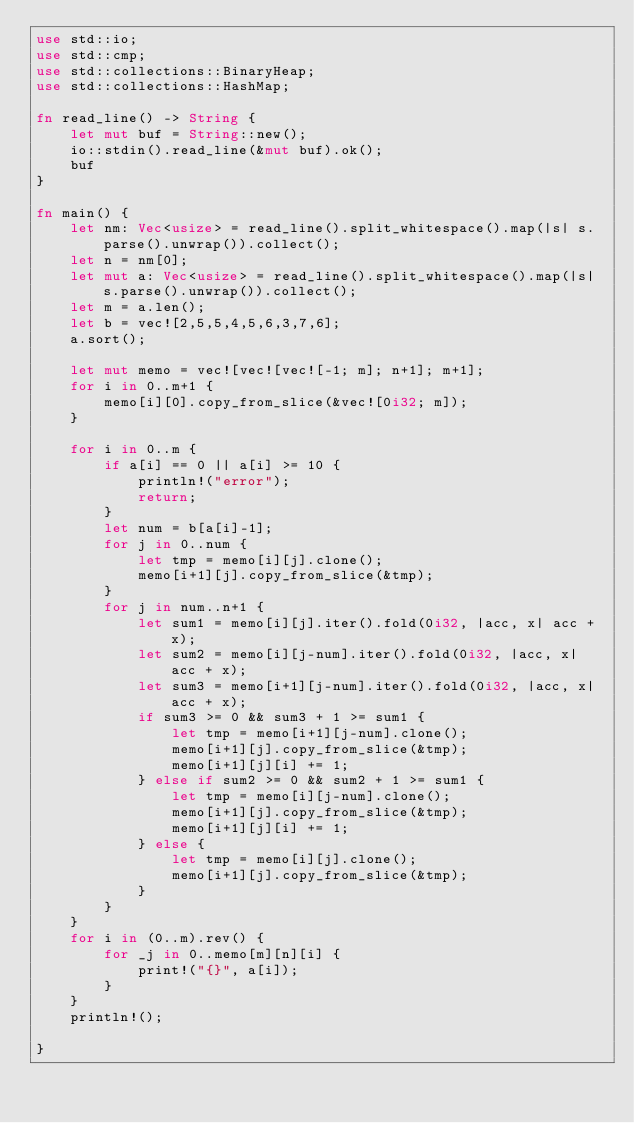<code> <loc_0><loc_0><loc_500><loc_500><_Rust_>use std::io;
use std::cmp;
use std::collections::BinaryHeap;
use std::collections::HashMap;

fn read_line() -> String {
    let mut buf = String::new();
    io::stdin().read_line(&mut buf).ok();
    buf
}

fn main() {
    let nm: Vec<usize> = read_line().split_whitespace().map(|s| s.parse().unwrap()).collect();
    let n = nm[0];
    let mut a: Vec<usize> = read_line().split_whitespace().map(|s| s.parse().unwrap()).collect();
    let m = a.len();
    let b = vec![2,5,5,4,5,6,3,7,6];
    a.sort();

    let mut memo = vec![vec![vec![-1; m]; n+1]; m+1];
    for i in 0..m+1 {
        memo[i][0].copy_from_slice(&vec![0i32; m]);
    }

    for i in 0..m {
        if a[i] == 0 || a[i] >= 10 {
            println!("error");
            return;
        }
        let num = b[a[i]-1];
        for j in 0..num {
            let tmp = memo[i][j].clone();
            memo[i+1][j].copy_from_slice(&tmp);
        }
        for j in num..n+1 {
            let sum1 = memo[i][j].iter().fold(0i32, |acc, x| acc + x);
            let sum2 = memo[i][j-num].iter().fold(0i32, |acc, x| acc + x);
            let sum3 = memo[i+1][j-num].iter().fold(0i32, |acc, x| acc + x);
            if sum3 >= 0 && sum3 + 1 >= sum1 {
                let tmp = memo[i+1][j-num].clone();
                memo[i+1][j].copy_from_slice(&tmp);
                memo[i+1][j][i] += 1;
            } else if sum2 >= 0 && sum2 + 1 >= sum1 {
                let tmp = memo[i][j-num].clone();
                memo[i+1][j].copy_from_slice(&tmp);
                memo[i+1][j][i] += 1;
            } else {
                let tmp = memo[i][j].clone();
                memo[i+1][j].copy_from_slice(&tmp);
            }
        }
    }
    for i in (0..m).rev() {
        for _j in 0..memo[m][n][i] {
            print!("{}", a[i]);
        }
    }
    println!();
    
}
</code> 